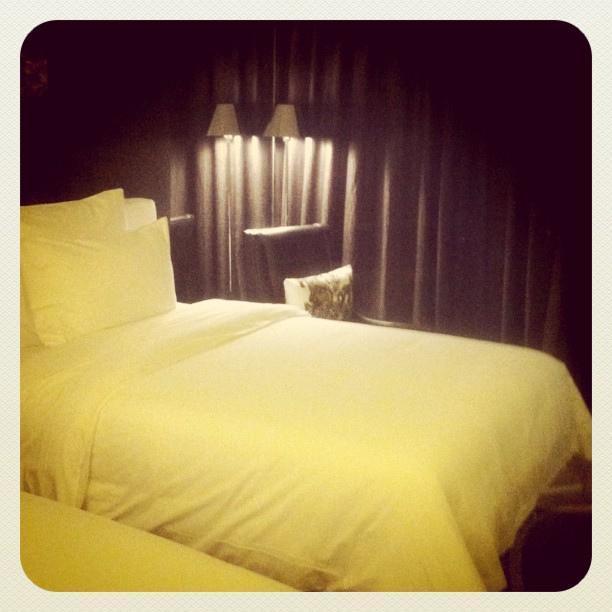How many lights are against the curtain?
Give a very brief answer. 2. How many beds are in the photo?
Give a very brief answer. 2. How many chairs are in the picture?
Give a very brief answer. 2. 